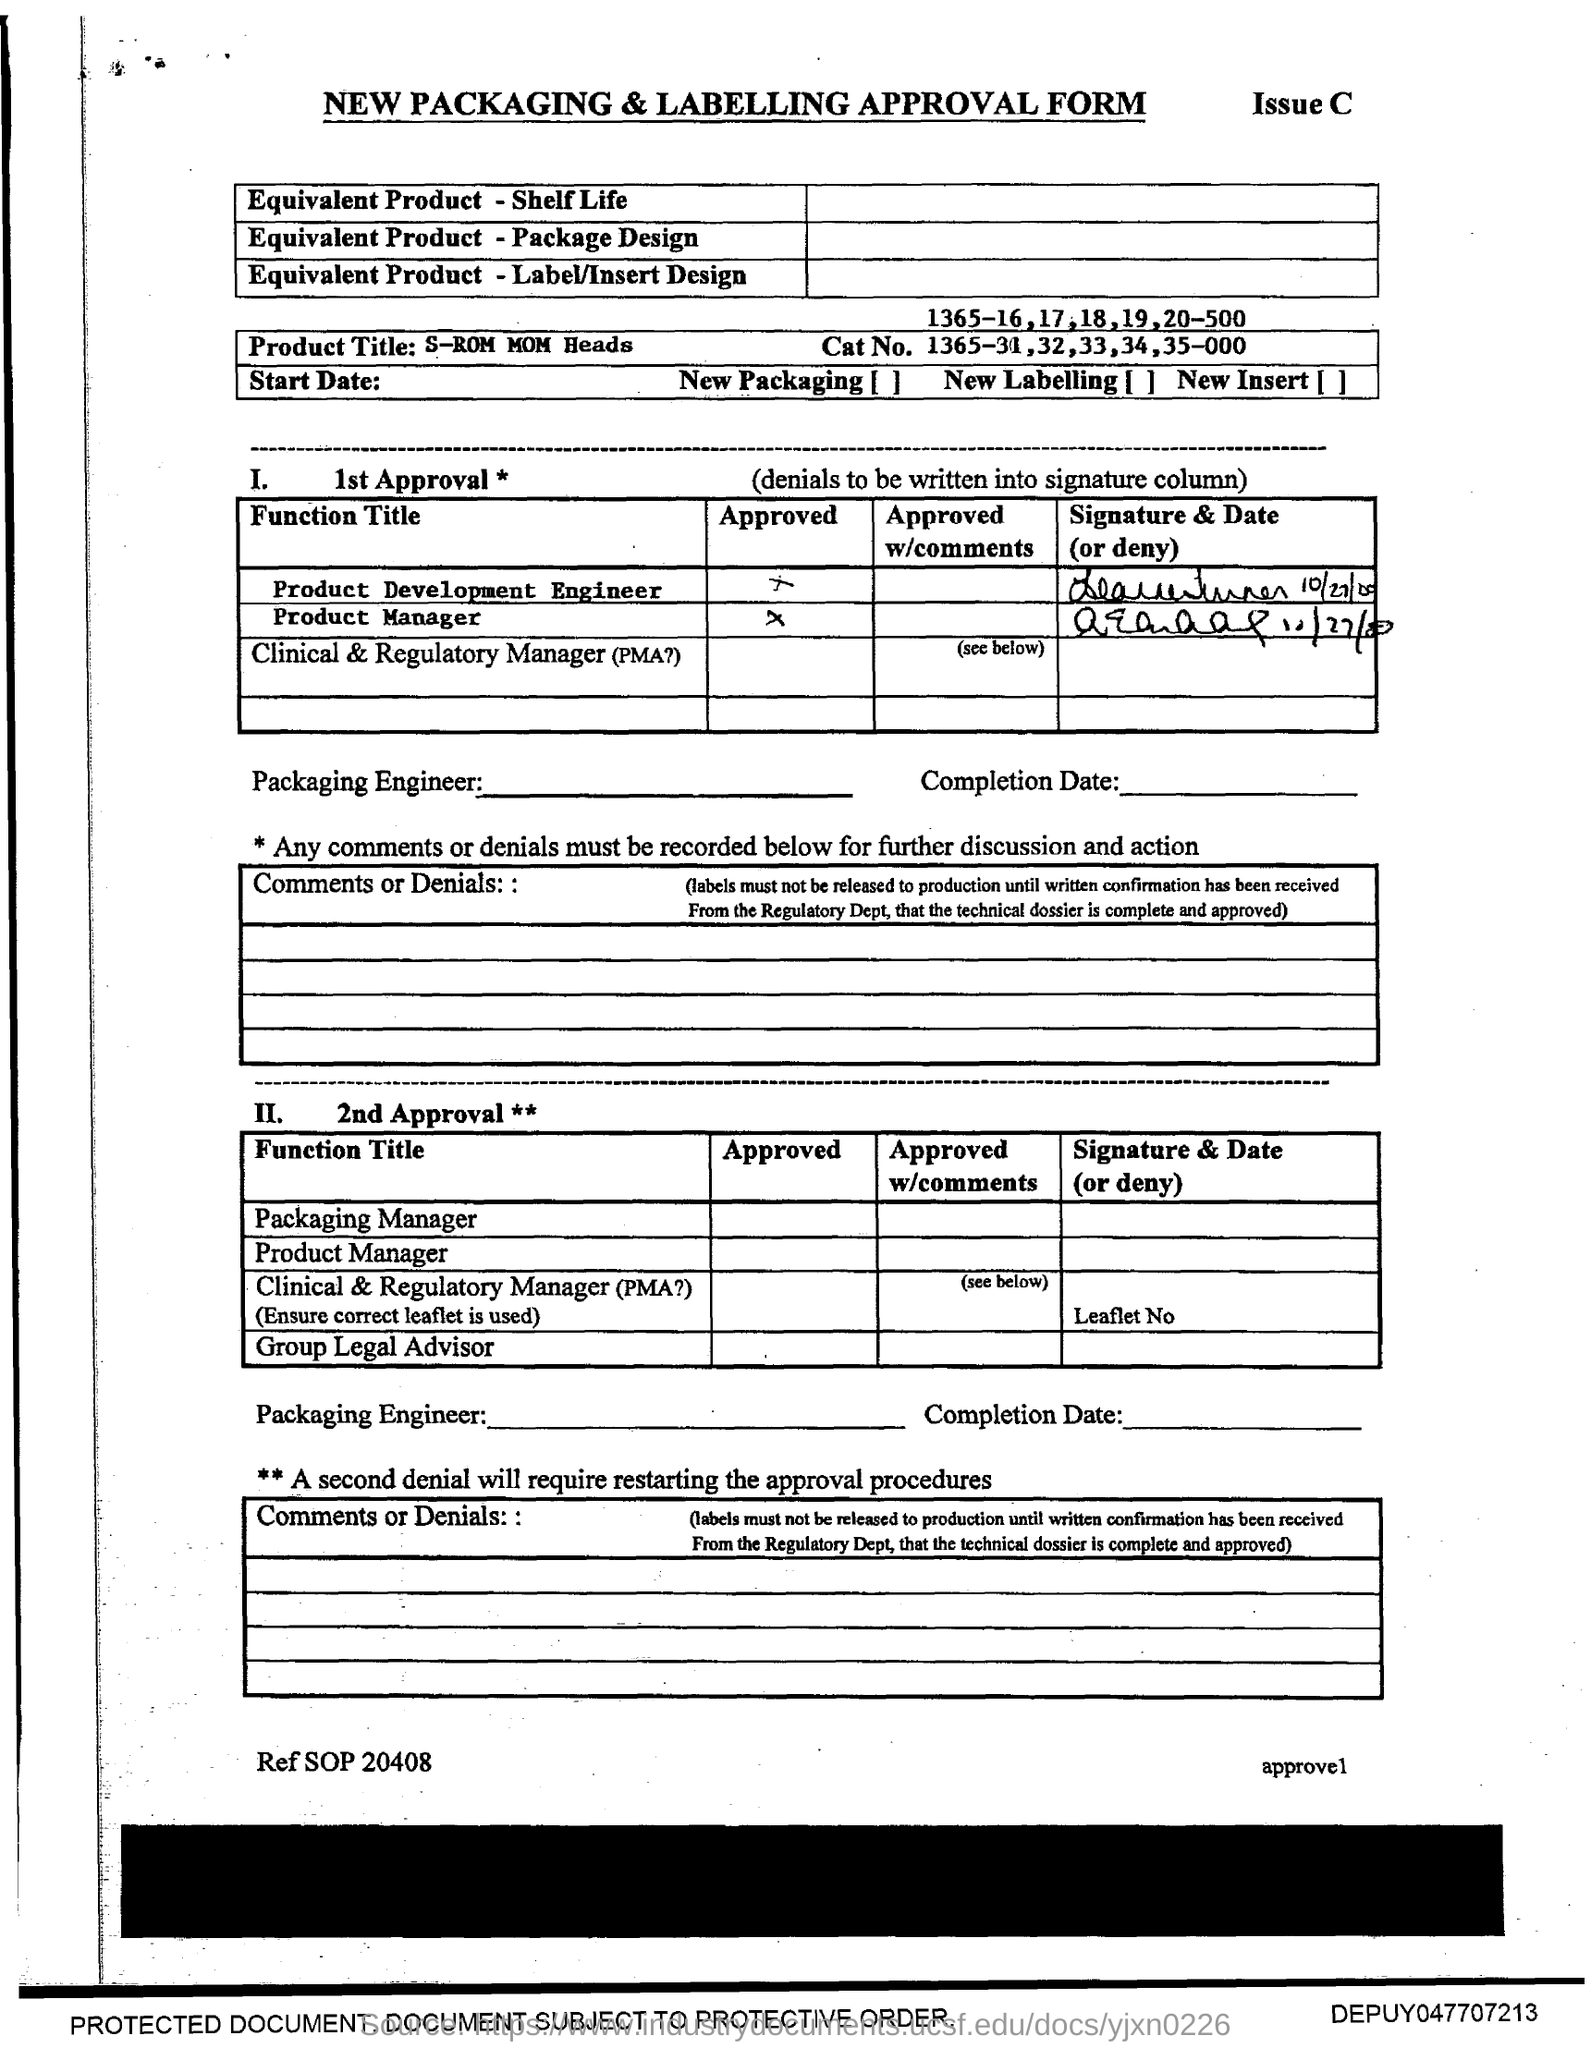Give some essential details in this illustration. The Cat No. refers to a specific product number, which is 1365-31, 32, 33, 34, 35-000, and so on. What is the name of the product? Is it an s-rom mom head? 